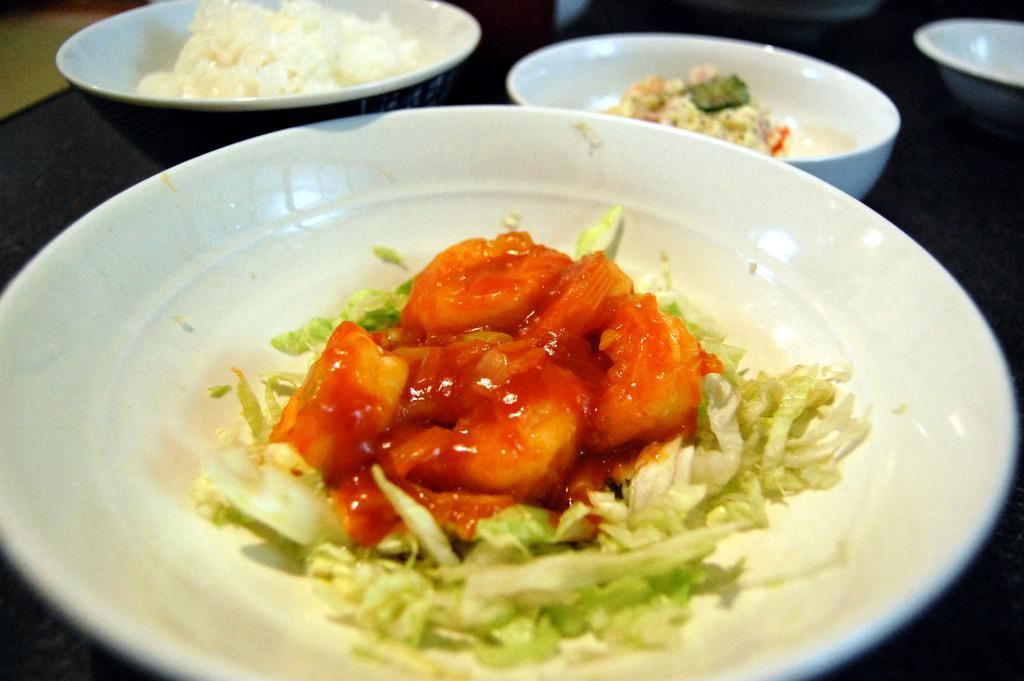What is on the plate that is visible in the image? There is food in a plate in the image. What other types of containers are present in the image? There are bowls in the image. Where are the plate and bowls located in the image? The plate and bowls are placed on a table. What type of invention is being demonstrated in the image? There is no invention being demonstrated in the image; it simply shows a plate with food and bowls on a table. 